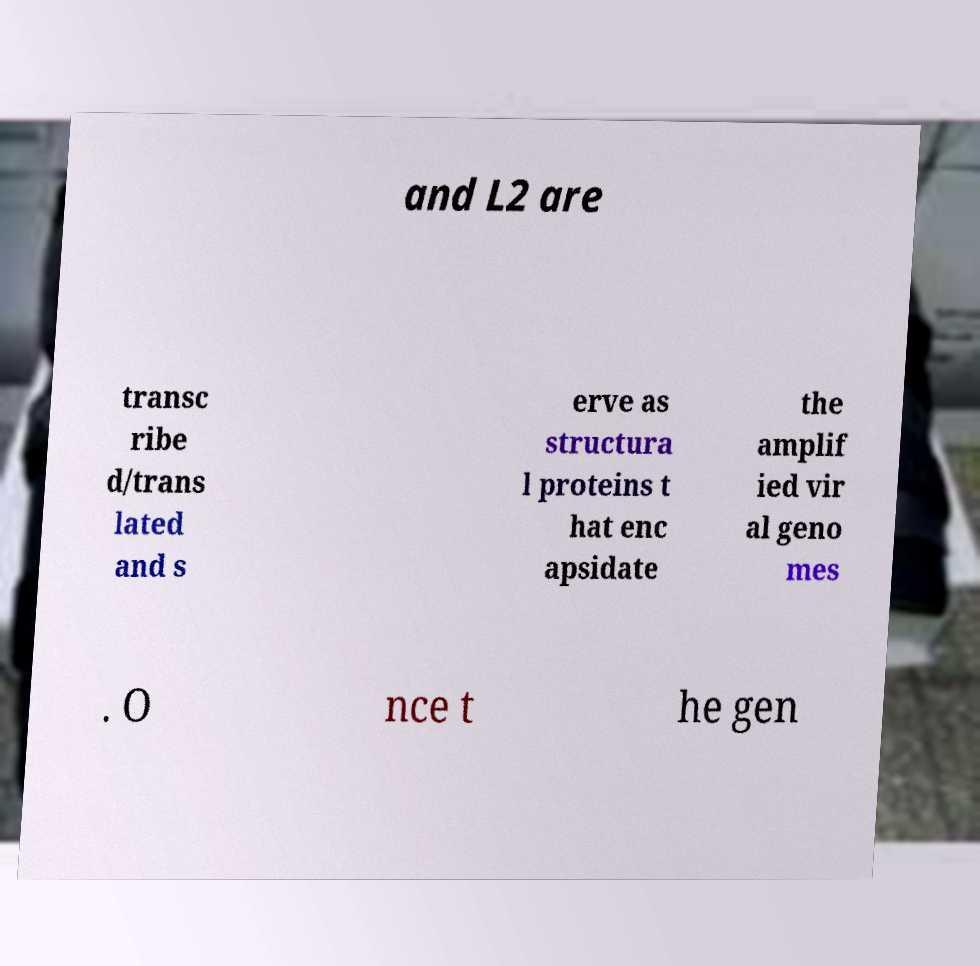Can you read and provide the text displayed in the image?This photo seems to have some interesting text. Can you extract and type it out for me? and L2 are transc ribe d/trans lated and s erve as structura l proteins t hat enc apsidate the amplif ied vir al geno mes . O nce t he gen 